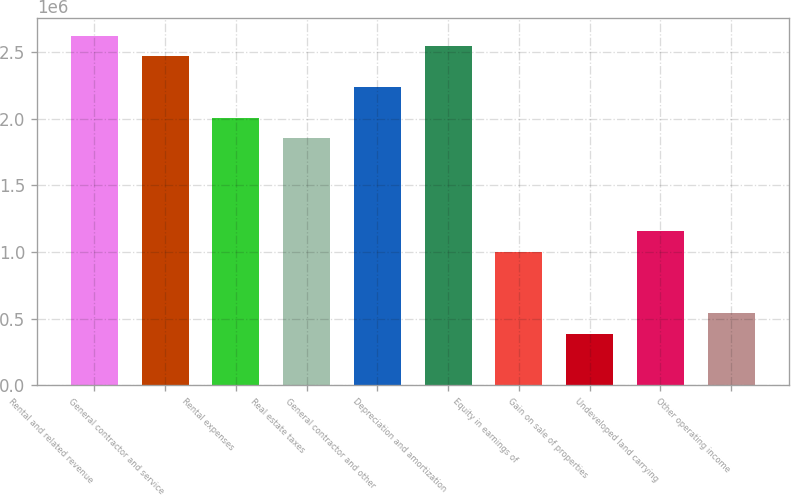Convert chart to OTSL. <chart><loc_0><loc_0><loc_500><loc_500><bar_chart><fcel>Rental and related revenue<fcel>General contractor and service<fcel>Rental expenses<fcel>Real estate taxes<fcel>General contractor and other<fcel>Depreciation and amortization<fcel>Equity in earnings of<fcel>Gain on sale of properties<fcel>Undeveloped land carrying<fcel>Other operating income<nl><fcel>2.62353e+06<fcel>2.4692e+06<fcel>2.00623e+06<fcel>1.8519e+06<fcel>2.23771e+06<fcel>2.54636e+06<fcel>1.00311e+06<fcel>385813<fcel>1.15744e+06<fcel>540138<nl></chart> 